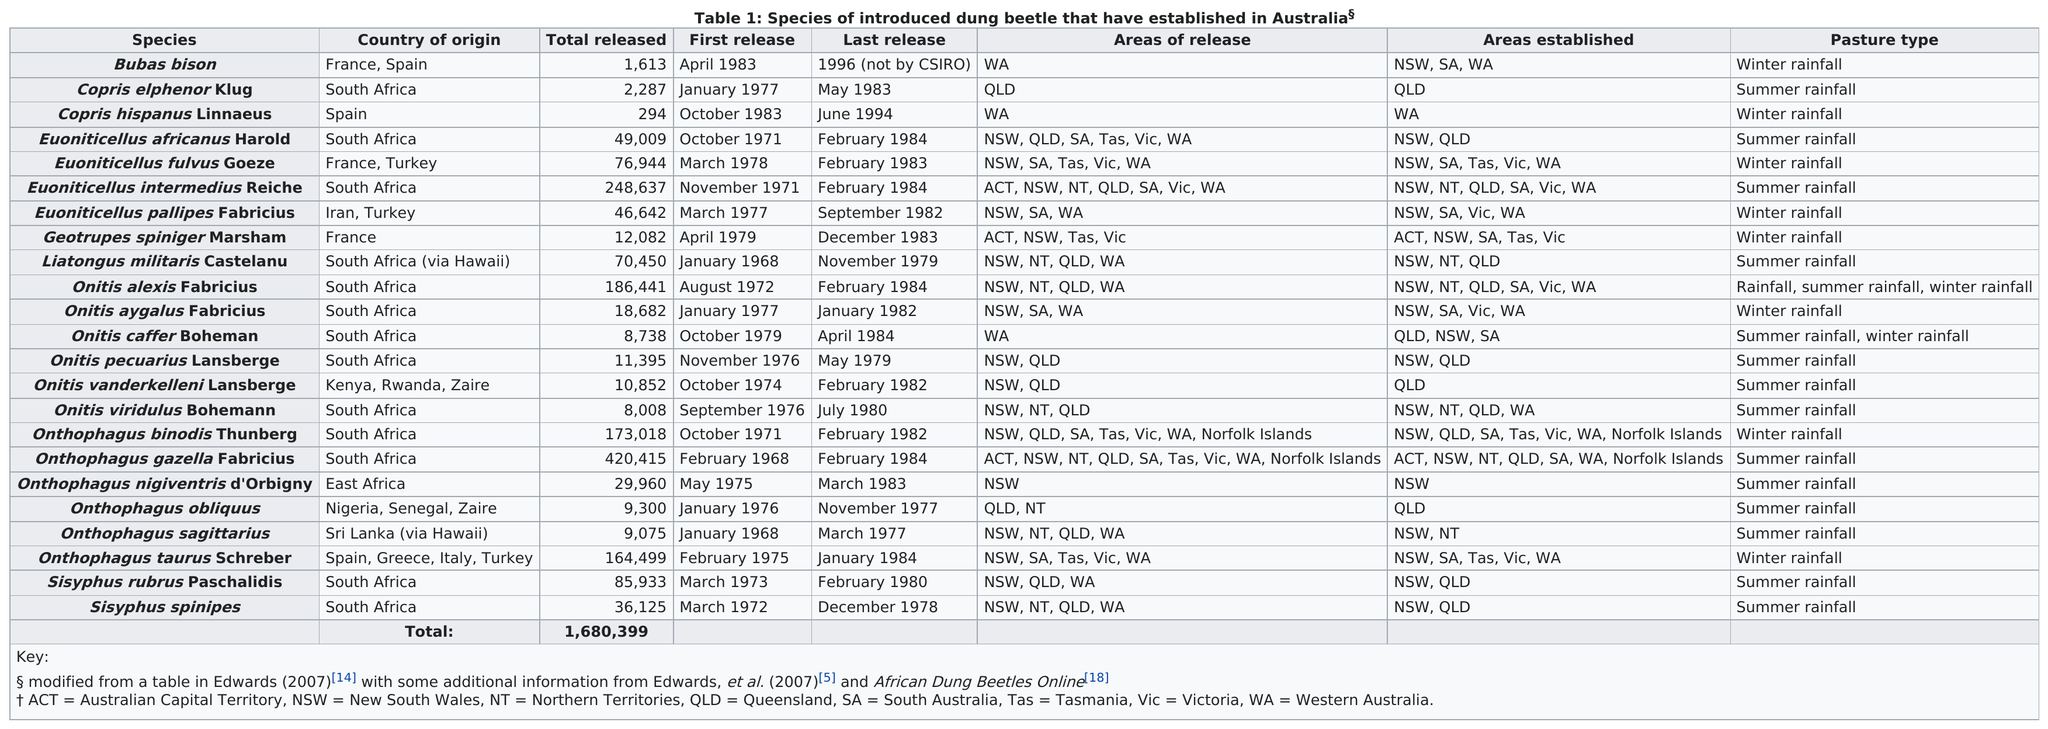Give some essential details in this illustration. The number of Onthophagus obliquus species released is 76633, while the number of Sisyphus rubrus paschalidis released is 76633. On October 27th, 1954, 1319 bison were released into Yellowstone National Park while only 1 copris hispanus linnaeus was released. In 1971, a total of three different species were released. In total, 70,450 Liatongus militaris castelanu were released. According to the provided information, more beetles originated from South Africa than from Spain. 